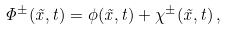<formula> <loc_0><loc_0><loc_500><loc_500>\Phi ^ { \pm } ( \vec { x } , t ) = \phi ( \vec { x } , t ) + \chi ^ { \pm } ( \vec { x } , t ) \, ,</formula> 